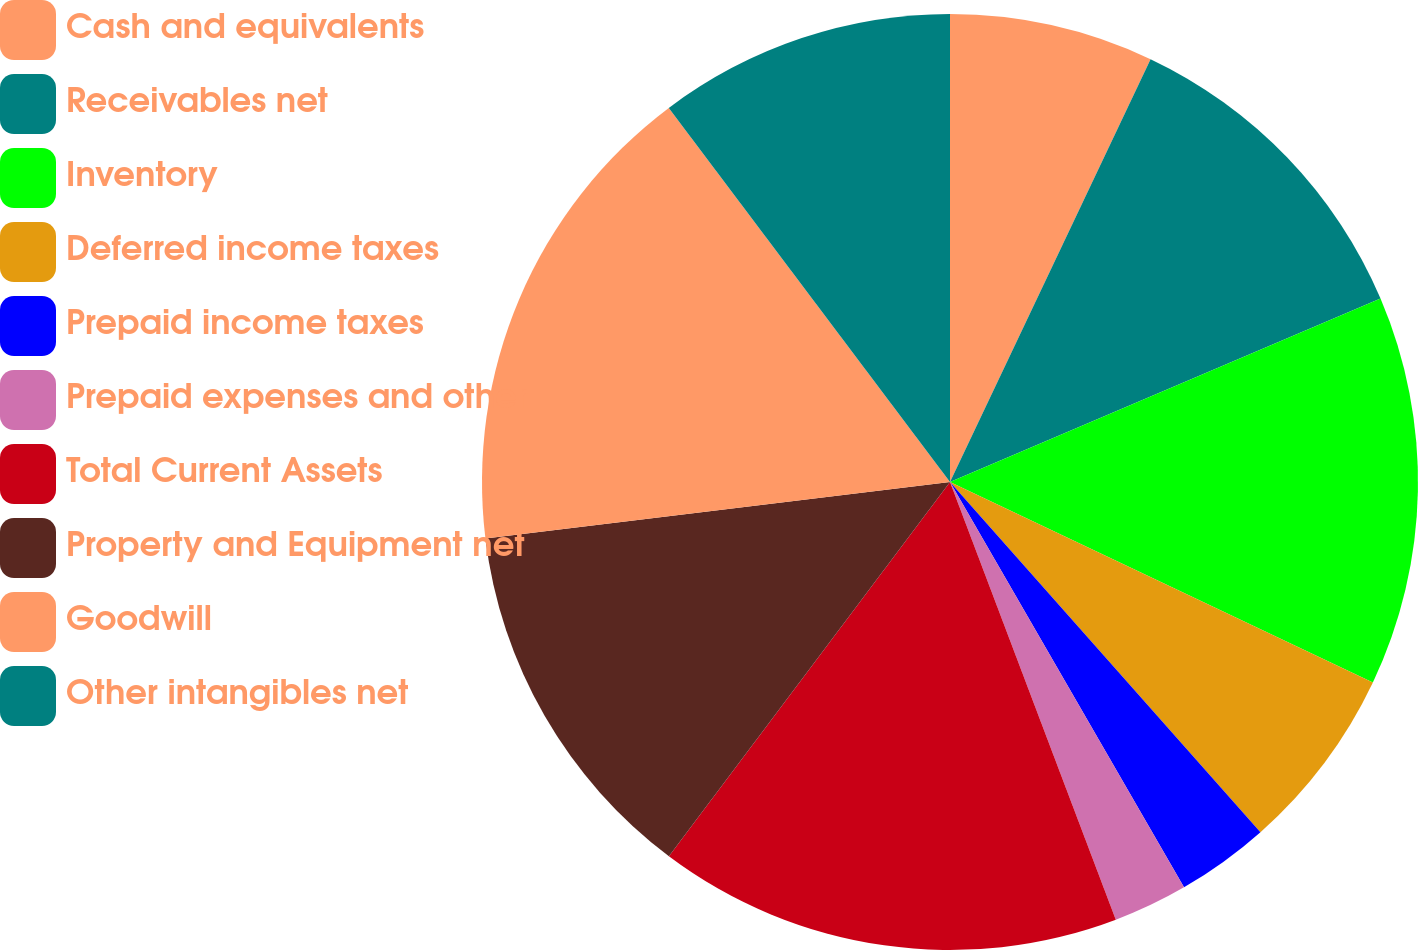<chart> <loc_0><loc_0><loc_500><loc_500><pie_chart><fcel>Cash and equivalents<fcel>Receivables net<fcel>Inventory<fcel>Deferred income taxes<fcel>Prepaid income taxes<fcel>Prepaid expenses and other<fcel>Total Current Assets<fcel>Property and Equipment net<fcel>Goodwill<fcel>Other intangibles net<nl><fcel>7.05%<fcel>11.54%<fcel>13.46%<fcel>6.41%<fcel>3.21%<fcel>2.57%<fcel>16.02%<fcel>12.82%<fcel>16.67%<fcel>10.26%<nl></chart> 